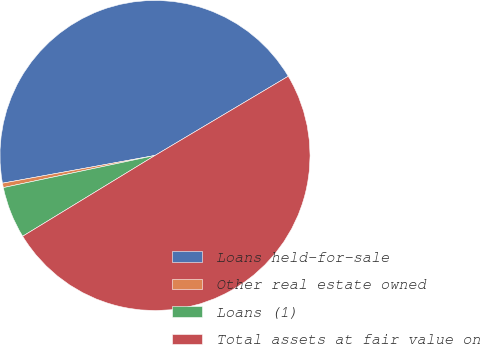Convert chart. <chart><loc_0><loc_0><loc_500><loc_500><pie_chart><fcel>Loans held-for-sale<fcel>Other real estate owned<fcel>Loans (1)<fcel>Total assets at fair value on<nl><fcel>44.33%<fcel>0.46%<fcel>5.4%<fcel>49.82%<nl></chart> 